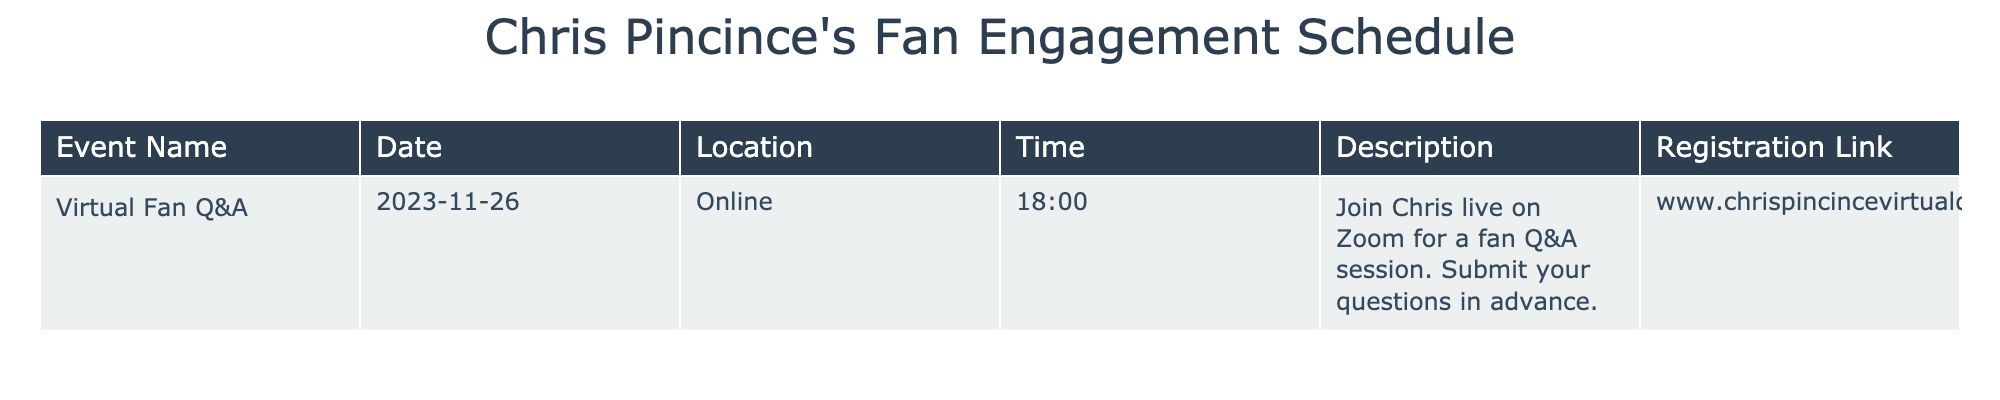What is the date of the Virtual Fan Q&A event? The table specifies the event name as "Virtual Fan Q&A" and the corresponding date listed is 2023-11-26.
Answer: 2023-11-26 What time does the Virtual Fan Q&A session start? According to the table, the time for the event titled "Virtual Fan Q&A" is 18:00.
Answer: 18:00 Is the Virtual Fan Q&A event held in person? The table indicates that the location for the "Virtual Fan Q&A" is "Online," meaning it is not an in-person event.
Answer: No How many fan engagement events are listed in the schedule? The table only contains one event listed, which is the "Virtual Fan Q&A," so the count is one.
Answer: 1 What is the registration link for the Virtual Fan Q&A event? The registration link for the event can be found in the table under the "Registration Link" column, which is "www.chrispincincevirtualqa.com."
Answer: www.chrispincincevirtualqa.com If Chris collects 50 questions for the Q&A session, and he answers 30 of them, what percentage of questions does he answer? From the problem statement, the number of questions answered is 30 and the total number of questions is 50. To find the percentage, we calculate (30/50) * 100, which gives us 60%.
Answer: 60% What is the full description of the Virtual Fan Q&A event? The full description provided in the table for the "Virtual Fan Q&A" is "Join Chris live on Zoom for a fan Q&A session. Submit your questions in advance."
Answer: Join Chris live on Zoom for a fan Q&A session. Submit your questions in advance Is the event scheduled for a weekend? The date of the event is November 26, 2023, which falls on a Sunday, confirming that the event is on a weekend.
Answer: Yes What can you expect to do during the Virtual Fan Q&A? The description in the table states that during the event, participants can join Chris live on Zoom for a Q&A session and submit their questions in advance.
Answer: Join Chris live on Zoom for a Q&A session and submit questions 